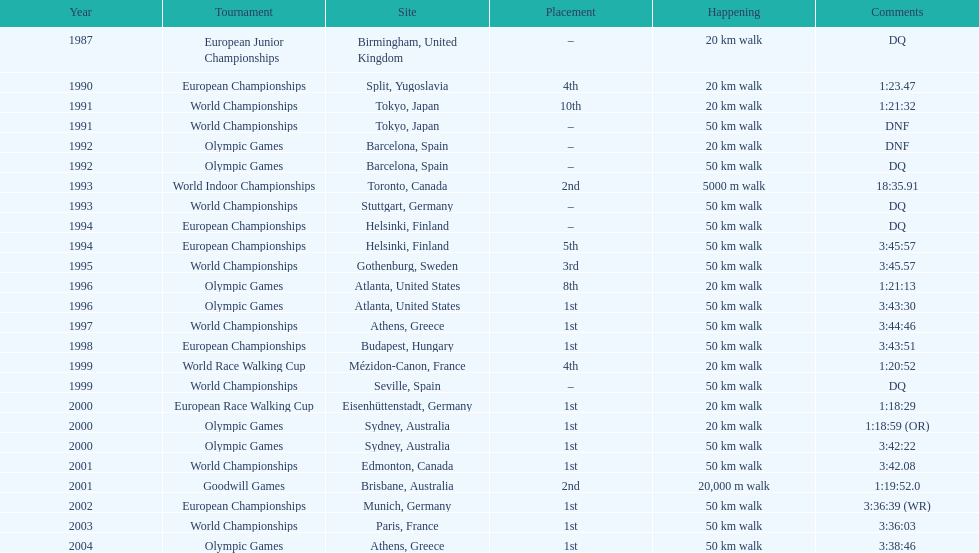In what year was korzeniowski's last competition? 2004. 